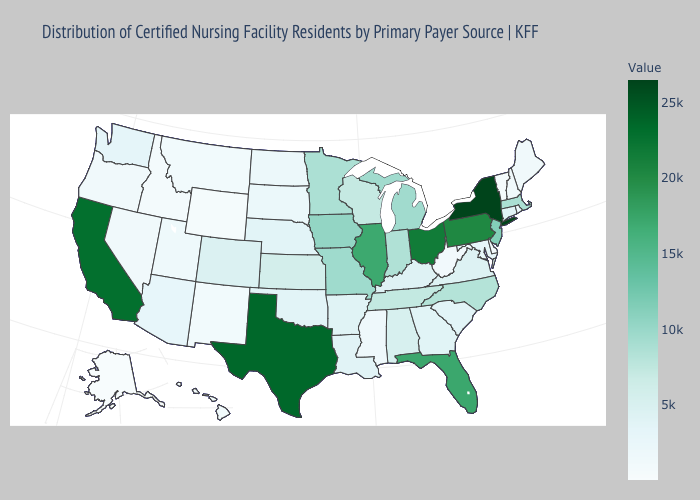Does the map have missing data?
Keep it brief. No. Which states have the highest value in the USA?
Give a very brief answer. New York. Does Maine have the highest value in the Northeast?
Concise answer only. No. Does Wyoming have the lowest value in the USA?
Be succinct. No. Among the states that border Mississippi , does Louisiana have the lowest value?
Write a very short answer. Yes. Which states hav the highest value in the Northeast?
Be succinct. New York. Which states have the highest value in the USA?
Quick response, please. New York. Which states have the lowest value in the USA?
Concise answer only. Alaska. Is the legend a continuous bar?
Keep it brief. Yes. Is the legend a continuous bar?
Short answer required. Yes. 